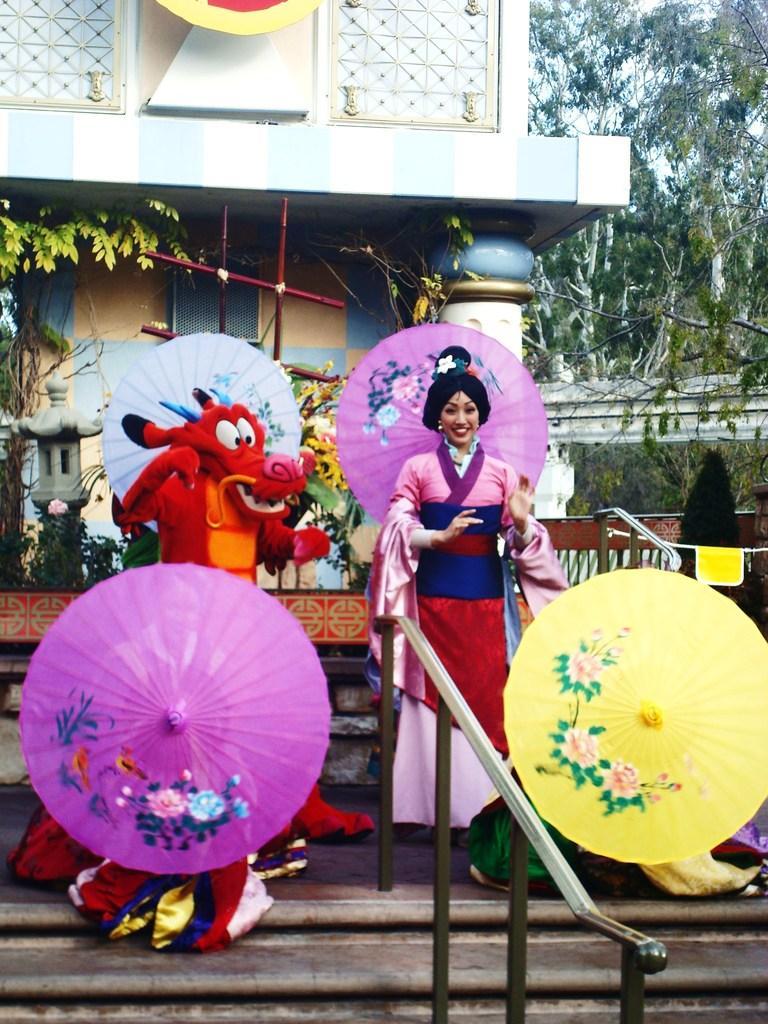How would you summarize this image in a sentence or two? In this image, we can see a clown and a lady wearing costume and there are umbrellas. In the background, there is a building and we can see trees, railings and there are plants and stairs. 